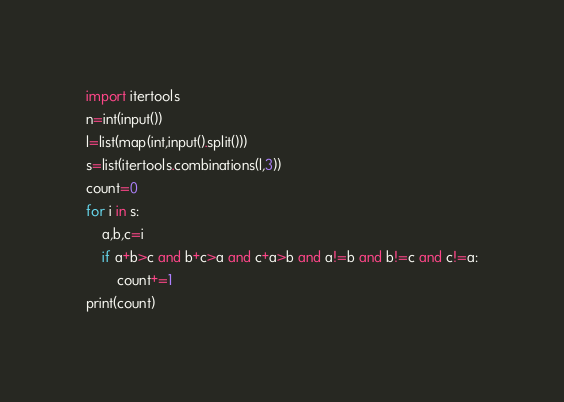Convert code to text. <code><loc_0><loc_0><loc_500><loc_500><_Python_>import itertools
n=int(input())
l=list(map(int,input().split()))
s=list(itertools.combinations(l,3))
count=0
for i in s:
	a,b,c=i
	if a+b>c and b+c>a and c+a>b and a!=b and b!=c and c!=a:
		count+=1
print(count)</code> 